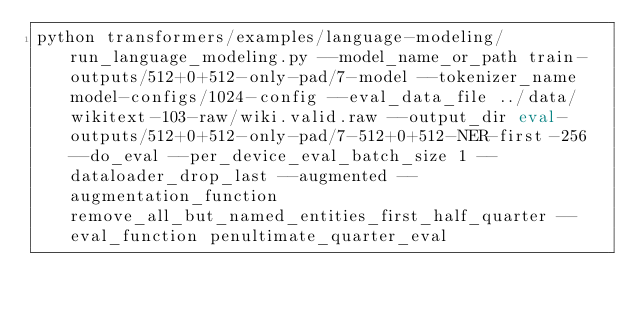Convert code to text. <code><loc_0><loc_0><loc_500><loc_500><_Bash_>python transformers/examples/language-modeling/run_language_modeling.py --model_name_or_path train-outputs/512+0+512-only-pad/7-model --tokenizer_name model-configs/1024-config --eval_data_file ../data/wikitext-103-raw/wiki.valid.raw --output_dir eval-outputs/512+0+512-only-pad/7-512+0+512-NER-first-256 --do_eval --per_device_eval_batch_size 1 --dataloader_drop_last --augmented --augmentation_function remove_all_but_named_entities_first_half_quarter --eval_function penultimate_quarter_eval</code> 